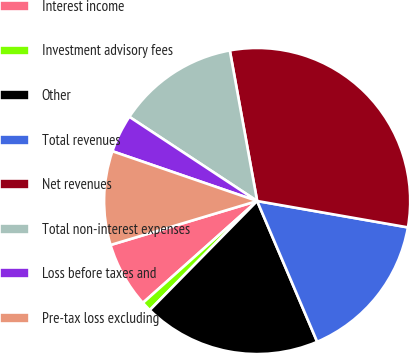Convert chart to OTSL. <chart><loc_0><loc_0><loc_500><loc_500><pie_chart><fcel>Interest income<fcel>Investment advisory fees<fcel>Other<fcel>Total revenues<fcel>Net revenues<fcel>Total non-interest expenses<fcel>Loss before taxes and<fcel>Pre-tax loss excluding<nl><fcel>6.95%<fcel>1.04%<fcel>18.79%<fcel>15.83%<fcel>30.62%<fcel>12.87%<fcel>4.0%<fcel>9.91%<nl></chart> 